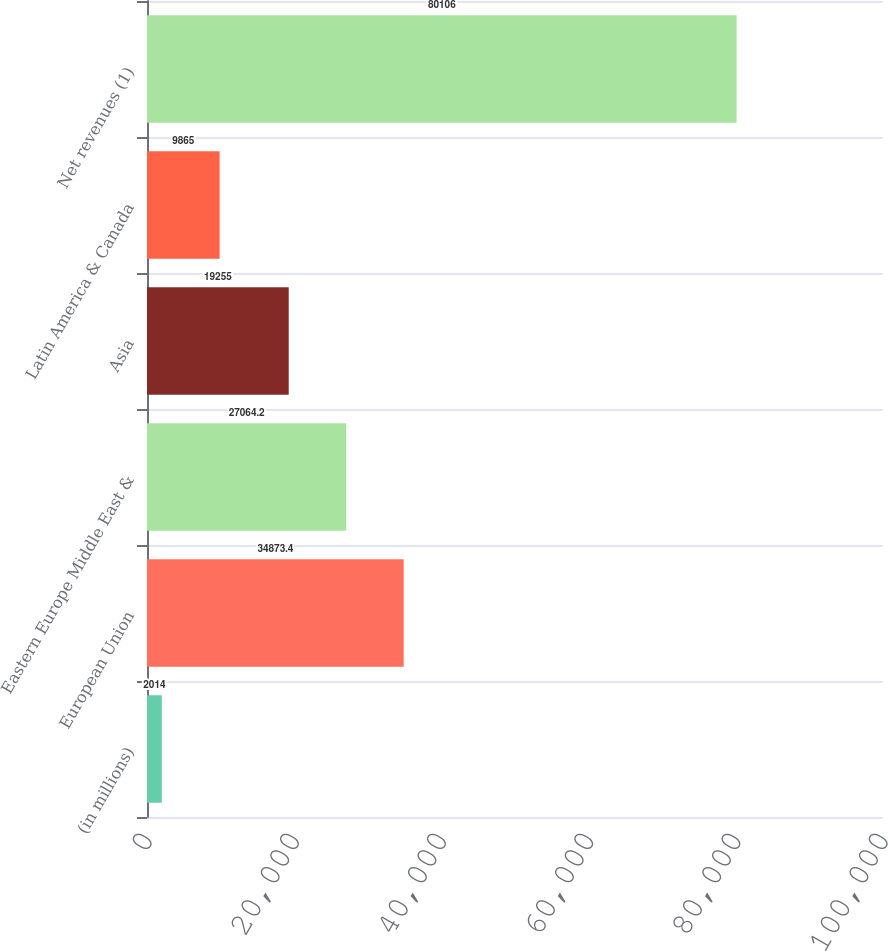Convert chart. <chart><loc_0><loc_0><loc_500><loc_500><bar_chart><fcel>(in millions)<fcel>European Union<fcel>Eastern Europe Middle East &<fcel>Asia<fcel>Latin America & Canada<fcel>Net revenues (1)<nl><fcel>2014<fcel>34873.4<fcel>27064.2<fcel>19255<fcel>9865<fcel>80106<nl></chart> 